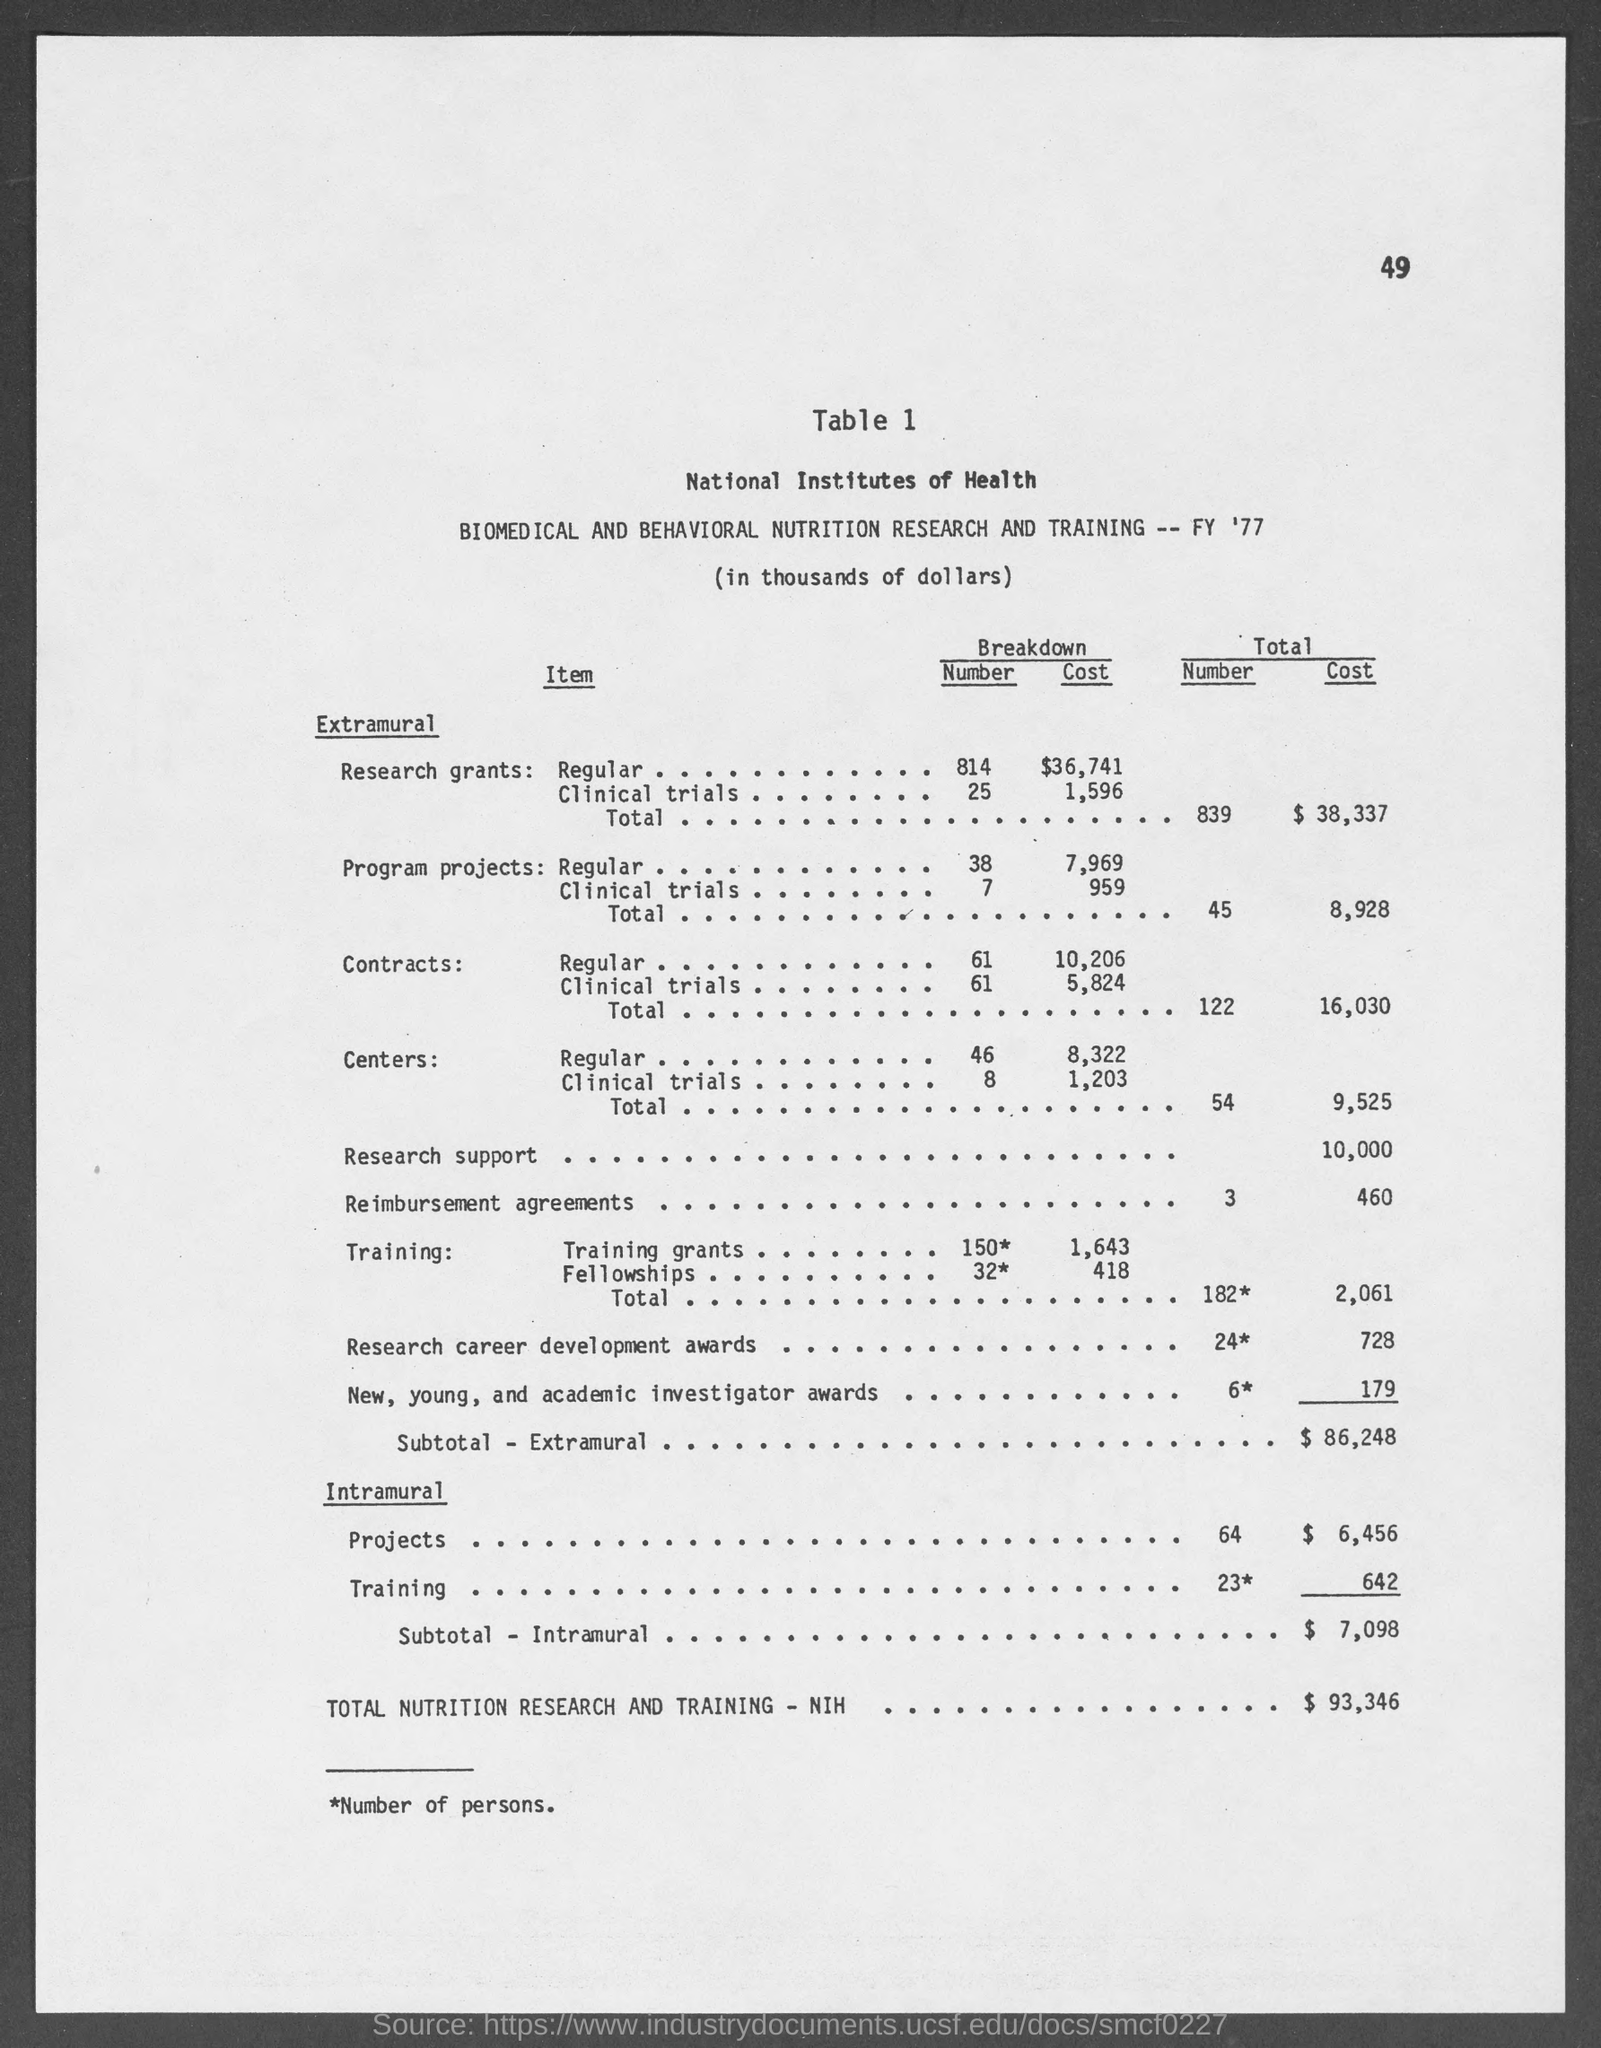Point out several critical features in this image. The total cost of extramural contracts is $16,030. The total cost of extramural research grants is $38,337. The total cost of intramural training is $642. The total cost of extramural program projects is 8,928. The total cost of extramural centers is 9,525. 